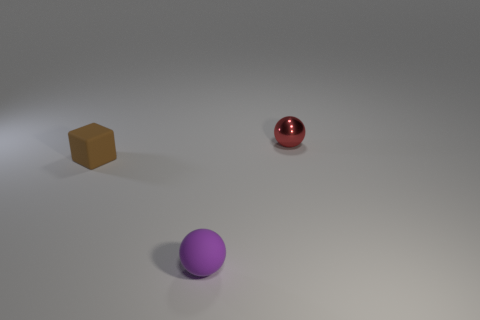The tiny object that is to the right of the sphere that is in front of the small matte block is what shape?
Provide a succinct answer. Sphere. There is a tiny red metallic thing; is it the same shape as the matte object that is in front of the rubber cube?
Keep it short and to the point. Yes. What is the color of the other matte ball that is the same size as the red ball?
Provide a short and direct response. Purple. Are there fewer tiny matte blocks right of the tiny rubber sphere than small brown cubes right of the cube?
Give a very brief answer. No. What is the shape of the small object in front of the matte object that is on the left side of the small sphere left of the red sphere?
Provide a succinct answer. Sphere. How many matte things are either purple balls or brown blocks?
Provide a succinct answer. 2. The thing behind the tiny object to the left of the sphere in front of the tiny red ball is what color?
Your answer should be compact. Red. There is another small object that is the same shape as the red shiny object; what is its color?
Ensure brevity in your answer.  Purple. Is there anything else that has the same color as the small cube?
Provide a short and direct response. No. What number of other objects are the same material as the purple sphere?
Provide a short and direct response. 1. 